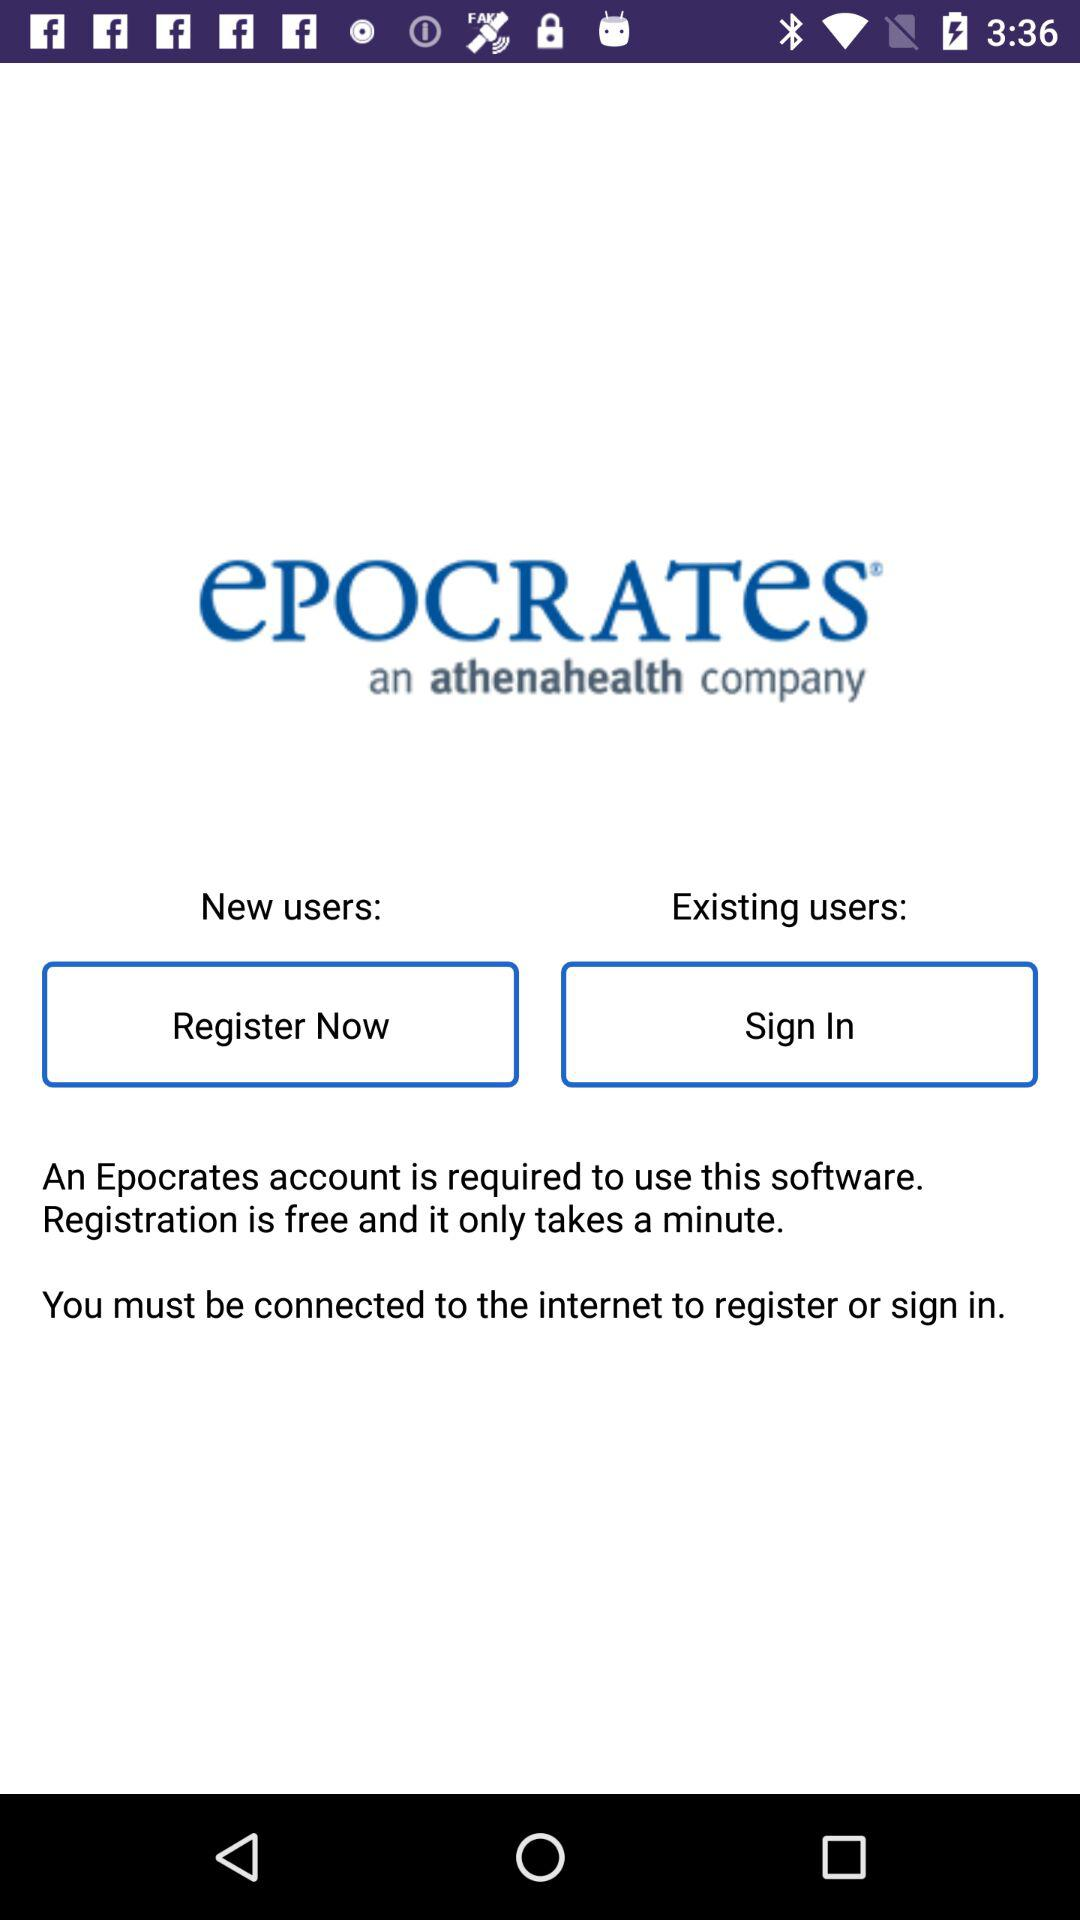How long will it take to register? It will take a minute to register. 